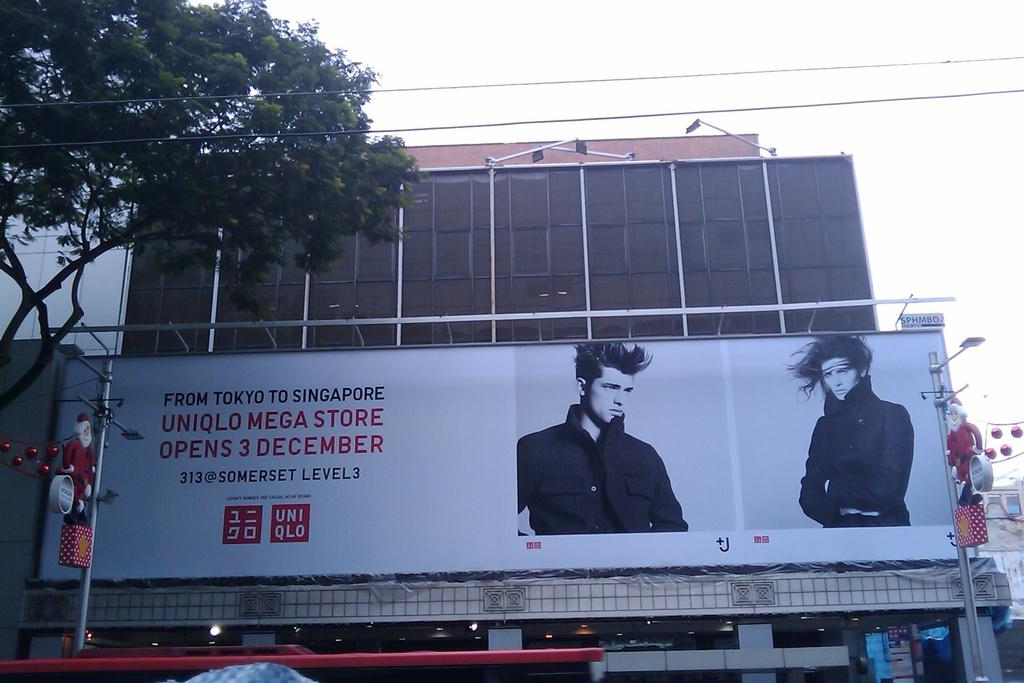Provide a one-sentence caption for the provided image. Large white Uniqlo billboard in front of a building. 